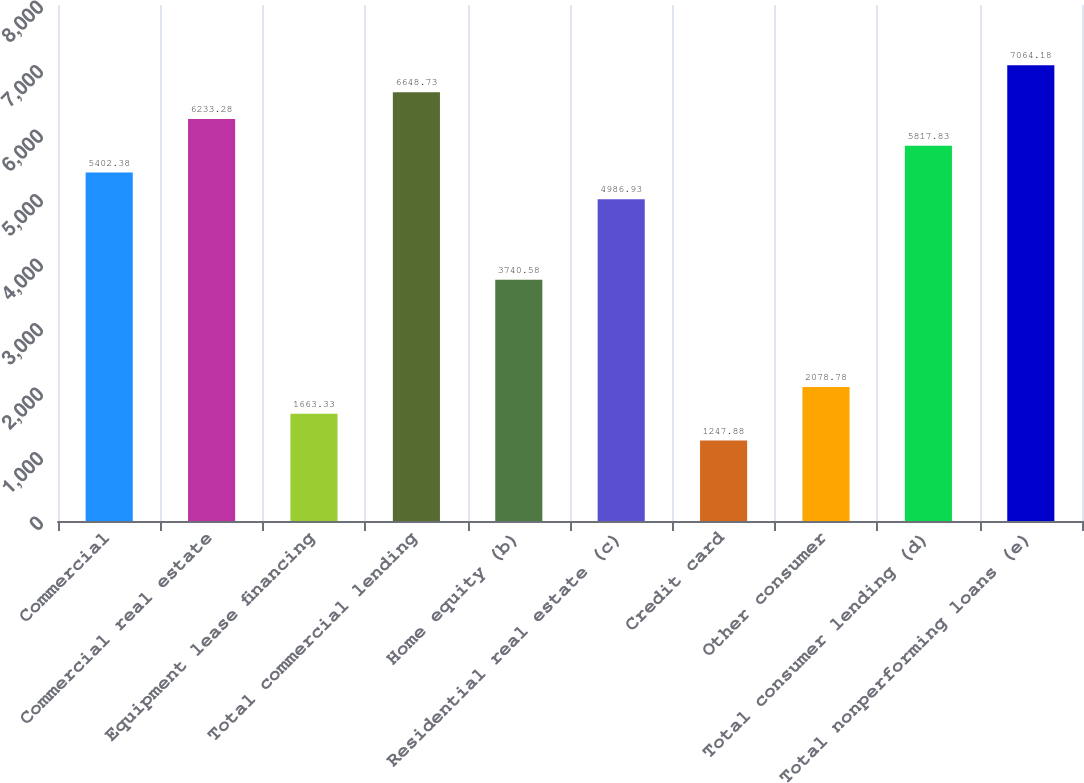<chart> <loc_0><loc_0><loc_500><loc_500><bar_chart><fcel>Commercial<fcel>Commercial real estate<fcel>Equipment lease financing<fcel>Total commercial lending<fcel>Home equity (b)<fcel>Residential real estate (c)<fcel>Credit card<fcel>Other consumer<fcel>Total consumer lending (d)<fcel>Total nonperforming loans (e)<nl><fcel>5402.38<fcel>6233.28<fcel>1663.33<fcel>6648.73<fcel>3740.58<fcel>4986.93<fcel>1247.88<fcel>2078.78<fcel>5817.83<fcel>7064.18<nl></chart> 